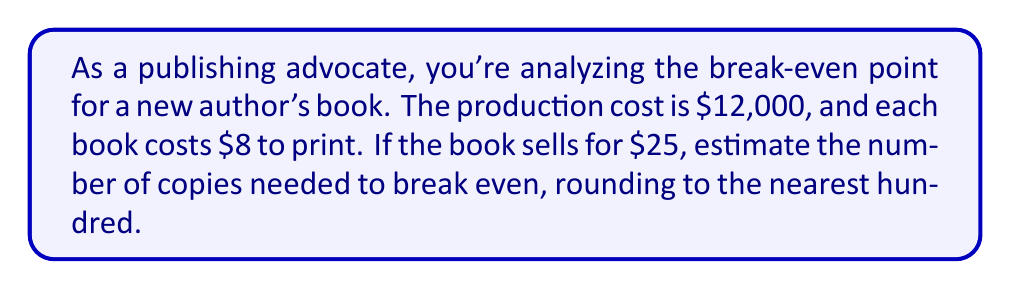Help me with this question. Let's approach this step-by-step:

1) Define variables:
   $x$ = number of books sold
   $25x$ = total revenue
   $12000 + 8x$ = total cost

2) At break-even point, revenue equals cost:
   $25x = 12000 + 8x$

3) Solve the equation:
   $25x - 8x = 12000$
   $17x = 12000$

4) Divide both sides by 17:
   $x = \frac{12000}{17} \approx 705.88$

5) Round to the nearest hundred:
   $705.88 \approx 700$

Therefore, approximately 700 copies need to be sold to break even.
Answer: 700 copies 